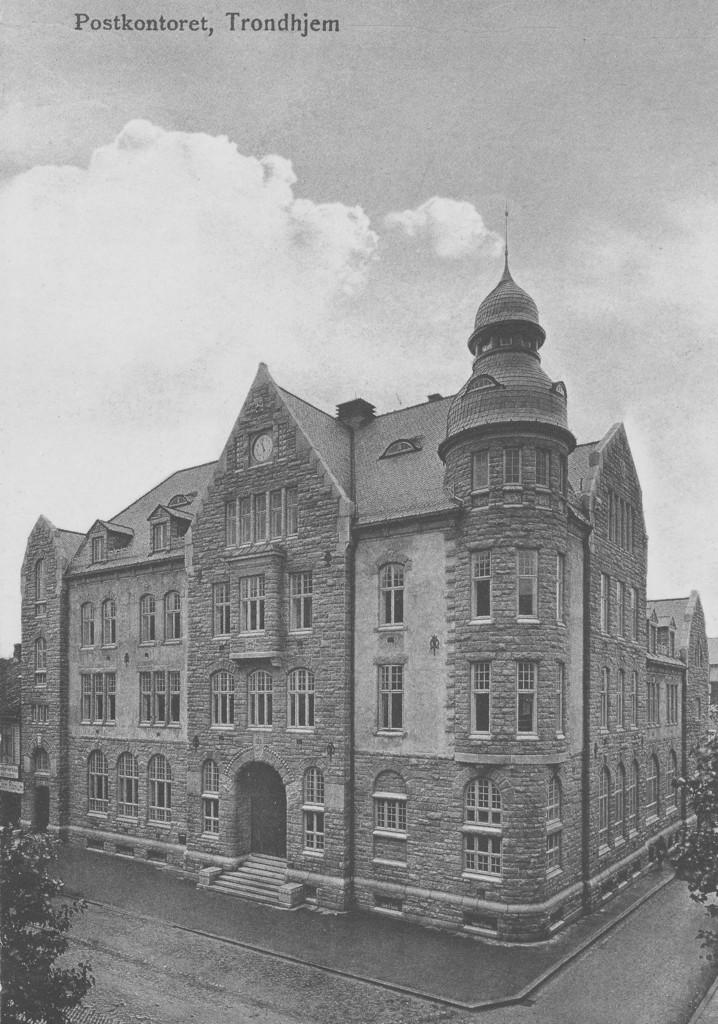What is the color scheme of the image? The image is in black and white. What type of vegetation can be seen on both sides of the image? There are trees on either side of the image. What structure is located in the middle of the image? There is a building in the middle of the image. What is visible at the top of the image? The sky is visible at the top of the image. What type of beast can be seen in the image? There is no beast present in the image; it features trees, a building, and the sky. 